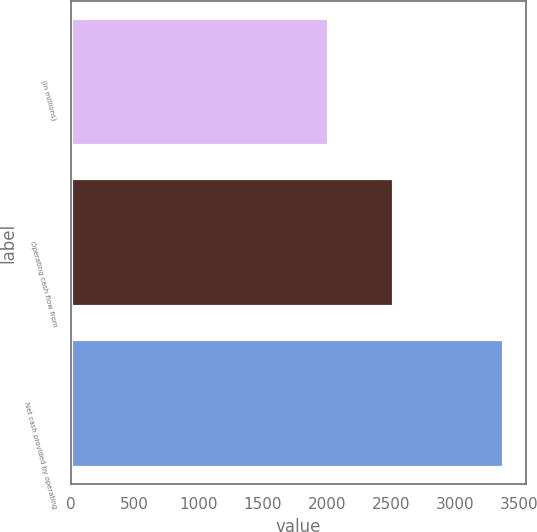<chart> <loc_0><loc_0><loc_500><loc_500><bar_chart><fcel>(in millions)<fcel>Operating cash flow from<fcel>Net cash provided by operating<nl><fcel>2016<fcel>2520<fcel>3384<nl></chart> 